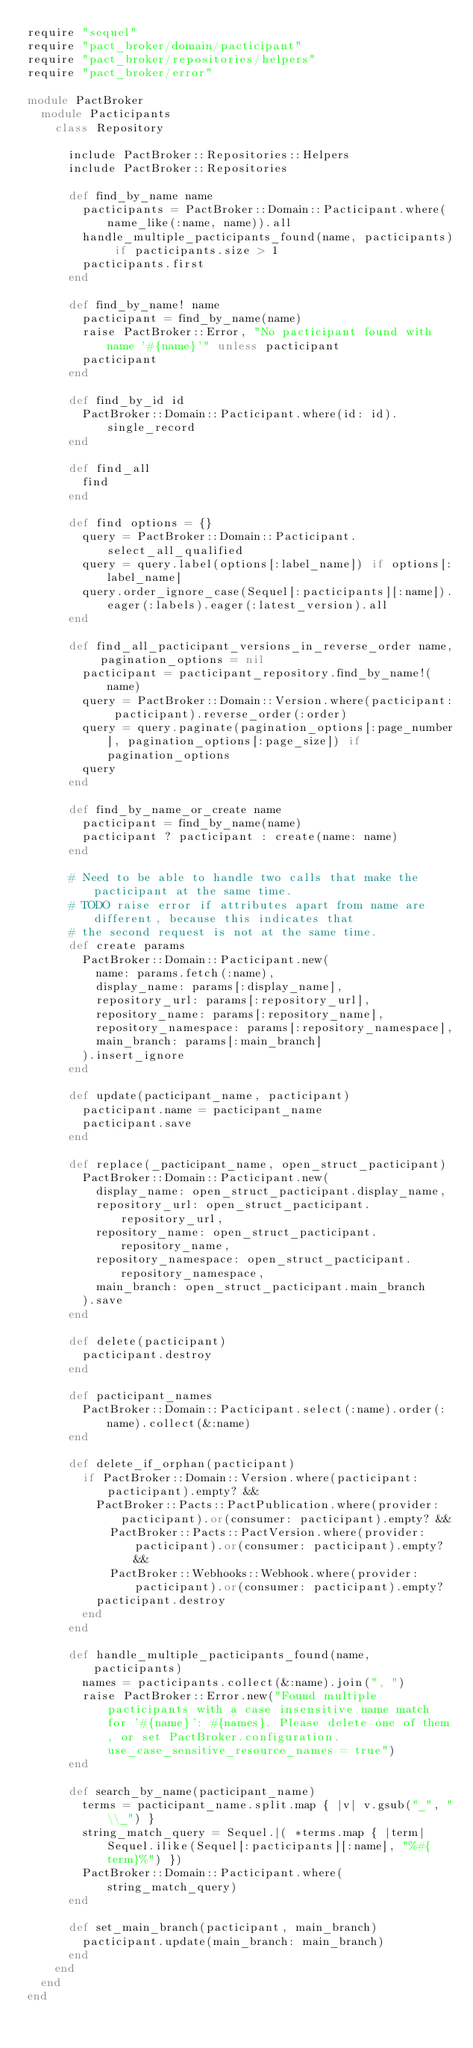<code> <loc_0><loc_0><loc_500><loc_500><_Ruby_>require "sequel"
require "pact_broker/domain/pacticipant"
require "pact_broker/repositories/helpers"
require "pact_broker/error"

module PactBroker
  module Pacticipants
    class Repository

      include PactBroker::Repositories::Helpers
      include PactBroker::Repositories

      def find_by_name name
        pacticipants = PactBroker::Domain::Pacticipant.where(name_like(:name, name)).all
        handle_multiple_pacticipants_found(name, pacticipants) if pacticipants.size > 1
        pacticipants.first
      end

      def find_by_name! name
        pacticipant = find_by_name(name)
        raise PactBroker::Error, "No pacticipant found with name '#{name}'" unless pacticipant
        pacticipant
      end

      def find_by_id id
        PactBroker::Domain::Pacticipant.where(id: id).single_record
      end

      def find_all
        find
      end

      def find options = {}
        query = PactBroker::Domain::Pacticipant.select_all_qualified
        query = query.label(options[:label_name]) if options[:label_name]
        query.order_ignore_case(Sequel[:pacticipants][:name]).eager(:labels).eager(:latest_version).all
      end

      def find_all_pacticipant_versions_in_reverse_order name, pagination_options = nil
        pacticipant = pacticipant_repository.find_by_name!(name)
        query = PactBroker::Domain::Version.where(pacticipant: pacticipant).reverse_order(:order)
        query = query.paginate(pagination_options[:page_number], pagination_options[:page_size]) if pagination_options
        query
      end

      def find_by_name_or_create name
        pacticipant = find_by_name(name)
        pacticipant ? pacticipant : create(name: name)
      end

      # Need to be able to handle two calls that make the pacticipant at the same time.
      # TODO raise error if attributes apart from name are different, because this indicates that
      # the second request is not at the same time.
      def create params
        PactBroker::Domain::Pacticipant.new(
          name: params.fetch(:name),
          display_name: params[:display_name],
          repository_url: params[:repository_url],
          repository_name: params[:repository_name],
          repository_namespace: params[:repository_namespace],
          main_branch: params[:main_branch]
        ).insert_ignore
      end

      def update(pacticipant_name, pacticipant)
        pacticipant.name = pacticipant_name
        pacticipant.save
      end

      def replace(_pacticipant_name, open_struct_pacticipant)
        PactBroker::Domain::Pacticipant.new(
          display_name: open_struct_pacticipant.display_name,
          repository_url: open_struct_pacticipant.repository_url,
          repository_name: open_struct_pacticipant.repository_name,
          repository_namespace: open_struct_pacticipant.repository_namespace,
          main_branch: open_struct_pacticipant.main_branch
        ).save
      end

      def delete(pacticipant)
        pacticipant.destroy
      end

      def pacticipant_names
        PactBroker::Domain::Pacticipant.select(:name).order(:name).collect(&:name)
      end

      def delete_if_orphan(pacticipant)
        if PactBroker::Domain::Version.where(pacticipant: pacticipant).empty? &&
          PactBroker::Pacts::PactPublication.where(provider: pacticipant).or(consumer: pacticipant).empty? &&
            PactBroker::Pacts::PactVersion.where(provider: pacticipant).or(consumer: pacticipant).empty? &&
            PactBroker::Webhooks::Webhook.where(provider: pacticipant).or(consumer: pacticipant).empty?
          pacticipant.destroy
        end
      end

      def handle_multiple_pacticipants_found(name, pacticipants)
        names = pacticipants.collect(&:name).join(", ")
        raise PactBroker::Error.new("Found multiple pacticipants with a case insensitive name match for '#{name}': #{names}. Please delete one of them, or set PactBroker.configuration.use_case_sensitive_resource_names = true")
      end

      def search_by_name(pacticipant_name)
        terms = pacticipant_name.split.map { |v| v.gsub("_", "\\_") }
        string_match_query = Sequel.|( *terms.map { |term| Sequel.ilike(Sequel[:pacticipants][:name], "%#{term}%") })
        PactBroker::Domain::Pacticipant.where(string_match_query)
      end

      def set_main_branch(pacticipant, main_branch)
        pacticipant.update(main_branch: main_branch)
      end
    end
  end
end
</code> 